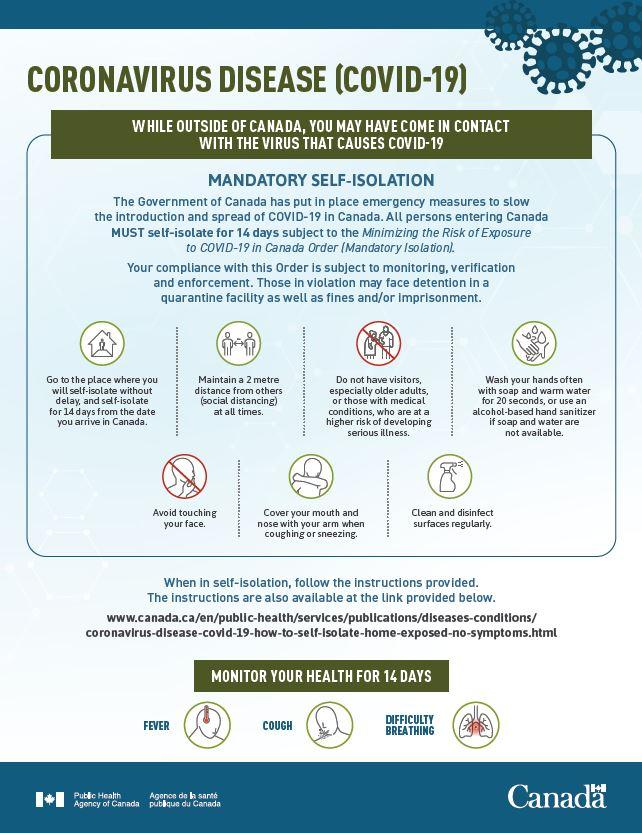Draw attention to some important aspects in this diagram. The most common symptoms of COVID-19 are fever, cough, and difficulty breathing. It is recommended to maintain a minimum safe distance of 2 meters between oneself and others in order to effectively control the spread of COVID-19 virus. 